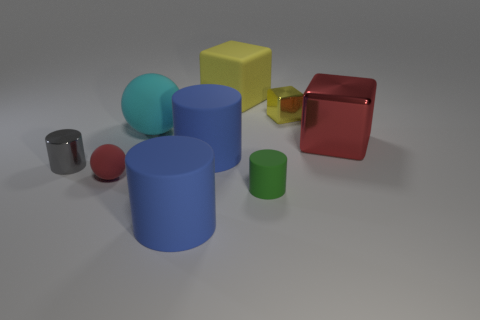Can you deduce anything about the size of the room or space in which these objects are placed? It's difficult to determine the size of the room from this image alone, as there's no clear reference point for scale. However, the shadows and lighting suggest the objects are placed in a mid-sized space, potentially a table or a platform, within an enclosed area. 